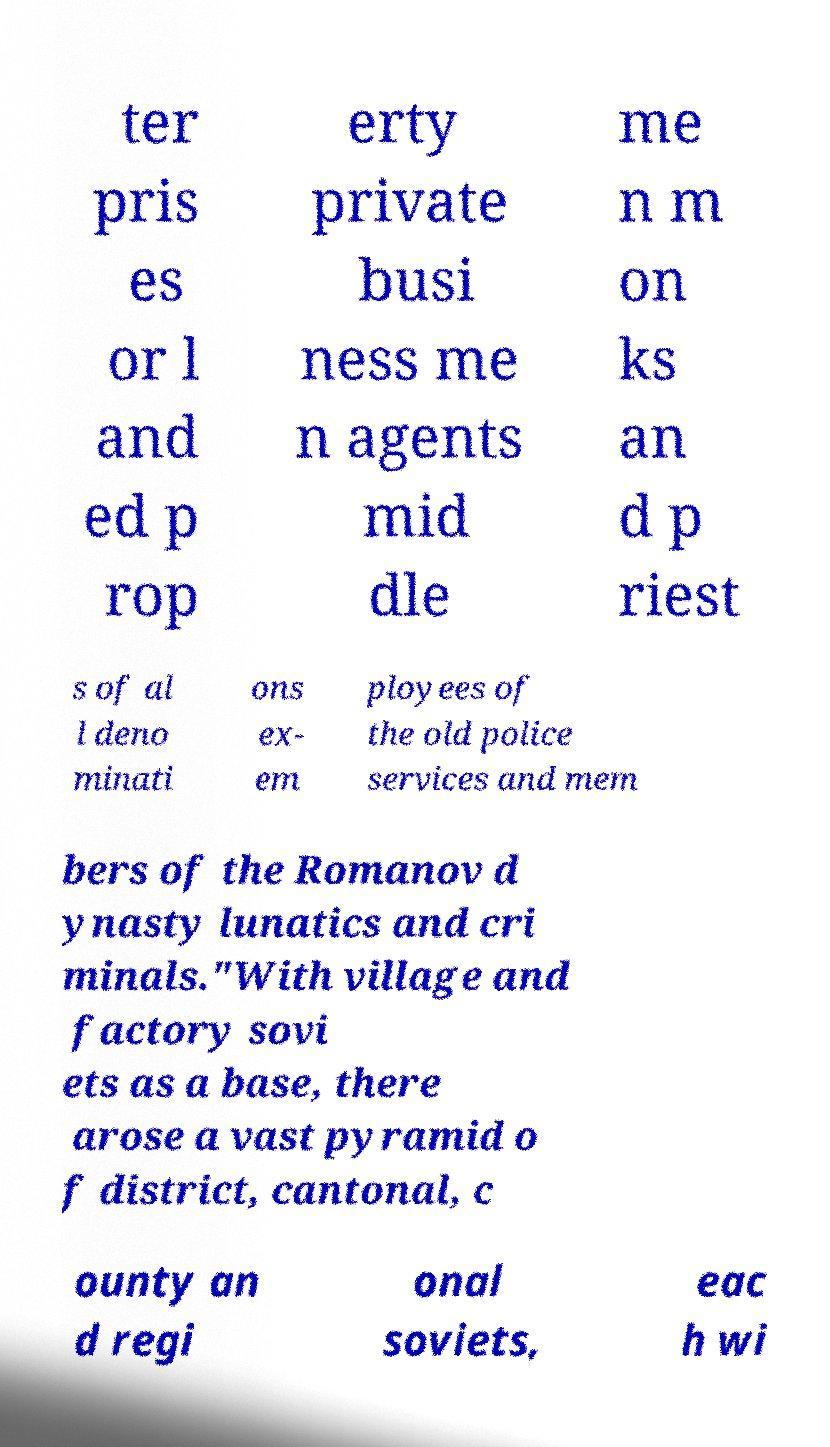Please identify and transcribe the text found in this image. ter pris es or l and ed p rop erty private busi ness me n agents mid dle me n m on ks an d p riest s of al l deno minati ons ex- em ployees of the old police services and mem bers of the Romanov d ynasty lunatics and cri minals."With village and factory sovi ets as a base, there arose a vast pyramid o f district, cantonal, c ounty an d regi onal soviets, eac h wi 